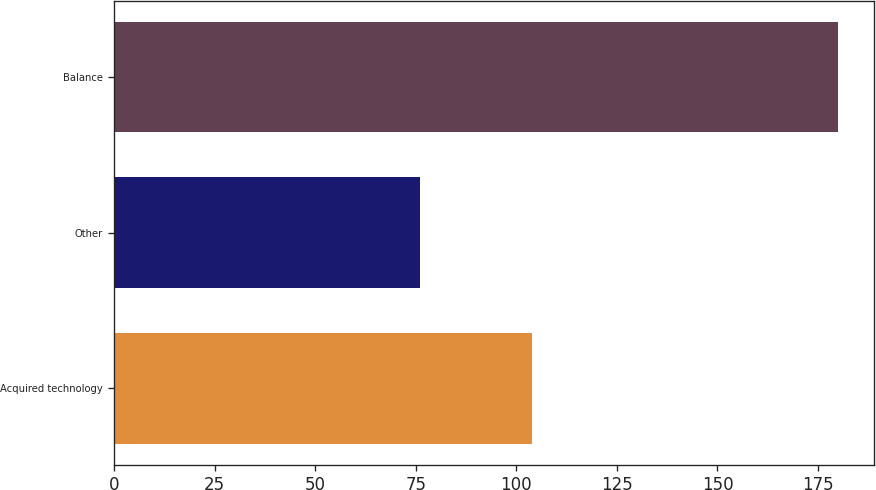Convert chart to OTSL. <chart><loc_0><loc_0><loc_500><loc_500><bar_chart><fcel>Acquired technology<fcel>Other<fcel>Balance<nl><fcel>104<fcel>76<fcel>180<nl></chart> 